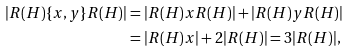<formula> <loc_0><loc_0><loc_500><loc_500>| R ( H ) \{ x , y \} R ( H ) | & = | R ( H ) x R ( H ) | + | R ( H ) y R ( H ) | \\ & = | R ( H ) x | + 2 | R ( H ) | = 3 | R ( H ) | ,</formula> 